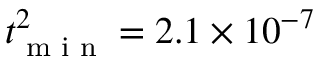<formula> <loc_0><loc_0><loc_500><loc_500>t _ { \min } ^ { 2 } = 2 . 1 \times 1 0 ^ { - 7 }</formula> 